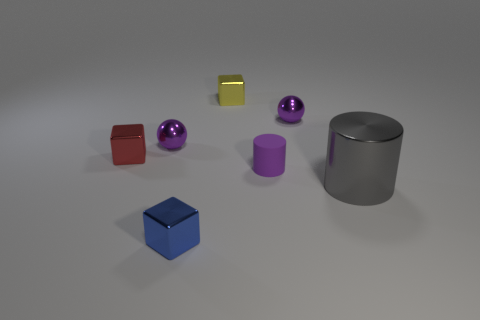Add 3 cubes. How many objects exist? 10 Subtract all cylinders. How many objects are left? 5 Subtract 1 purple cylinders. How many objects are left? 6 Subtract all purple spheres. Subtract all tiny metal spheres. How many objects are left? 3 Add 1 small purple cylinders. How many small purple cylinders are left? 2 Add 1 big green metallic objects. How many big green metallic objects exist? 1 